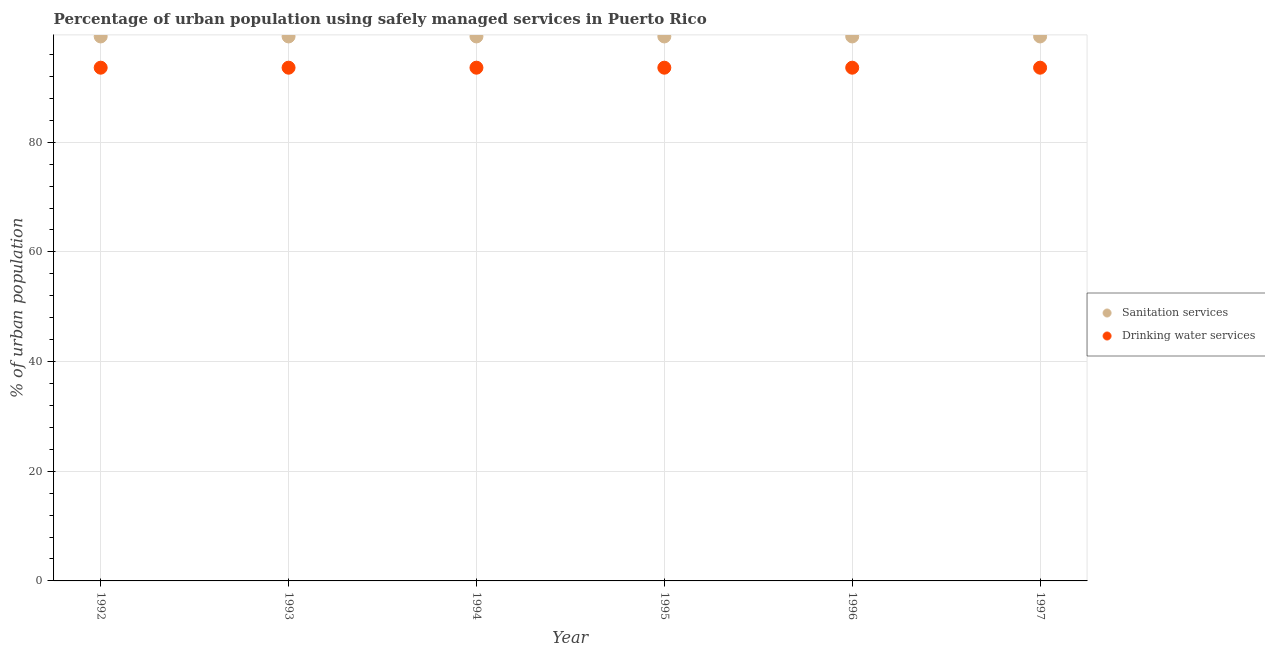Is the number of dotlines equal to the number of legend labels?
Give a very brief answer. Yes. What is the percentage of urban population who used sanitation services in 1993?
Your response must be concise. 99.3. Across all years, what is the maximum percentage of urban population who used drinking water services?
Ensure brevity in your answer.  93.6. Across all years, what is the minimum percentage of urban population who used sanitation services?
Ensure brevity in your answer.  99.3. What is the total percentage of urban population who used sanitation services in the graph?
Your answer should be very brief. 595.8. What is the difference between the percentage of urban population who used sanitation services in 1993 and that in 1995?
Provide a succinct answer. 0. What is the difference between the percentage of urban population who used drinking water services in 1996 and the percentage of urban population who used sanitation services in 1995?
Provide a succinct answer. -5.7. What is the average percentage of urban population who used drinking water services per year?
Make the answer very short. 93.6. In the year 1994, what is the difference between the percentage of urban population who used sanitation services and percentage of urban population who used drinking water services?
Your answer should be very brief. 5.7. What is the ratio of the percentage of urban population who used sanitation services in 1994 to that in 1996?
Keep it short and to the point. 1. Is the percentage of urban population who used sanitation services in 1992 less than that in 1994?
Make the answer very short. No. Is the difference between the percentage of urban population who used drinking water services in 1992 and 1996 greater than the difference between the percentage of urban population who used sanitation services in 1992 and 1996?
Offer a terse response. No. What is the difference between the highest and the second highest percentage of urban population who used drinking water services?
Provide a succinct answer. 0. What is the difference between the highest and the lowest percentage of urban population who used sanitation services?
Your answer should be very brief. 0. How many years are there in the graph?
Offer a very short reply. 6. What is the difference between two consecutive major ticks on the Y-axis?
Offer a terse response. 20. Does the graph contain any zero values?
Offer a very short reply. No. Where does the legend appear in the graph?
Keep it short and to the point. Center right. How many legend labels are there?
Offer a terse response. 2. What is the title of the graph?
Make the answer very short. Percentage of urban population using safely managed services in Puerto Rico. What is the label or title of the Y-axis?
Your answer should be very brief. % of urban population. What is the % of urban population of Sanitation services in 1992?
Your response must be concise. 99.3. What is the % of urban population of Drinking water services in 1992?
Offer a very short reply. 93.6. What is the % of urban population of Sanitation services in 1993?
Your response must be concise. 99.3. What is the % of urban population in Drinking water services in 1993?
Provide a succinct answer. 93.6. What is the % of urban population of Sanitation services in 1994?
Give a very brief answer. 99.3. What is the % of urban population in Drinking water services in 1994?
Provide a succinct answer. 93.6. What is the % of urban population in Sanitation services in 1995?
Provide a short and direct response. 99.3. What is the % of urban population of Drinking water services in 1995?
Offer a terse response. 93.6. What is the % of urban population in Sanitation services in 1996?
Offer a terse response. 99.3. What is the % of urban population in Drinking water services in 1996?
Your answer should be compact. 93.6. What is the % of urban population in Sanitation services in 1997?
Ensure brevity in your answer.  99.3. What is the % of urban population of Drinking water services in 1997?
Your response must be concise. 93.6. Across all years, what is the maximum % of urban population of Sanitation services?
Keep it short and to the point. 99.3. Across all years, what is the maximum % of urban population of Drinking water services?
Your answer should be compact. 93.6. Across all years, what is the minimum % of urban population of Sanitation services?
Keep it short and to the point. 99.3. Across all years, what is the minimum % of urban population of Drinking water services?
Provide a succinct answer. 93.6. What is the total % of urban population of Sanitation services in the graph?
Your answer should be compact. 595.8. What is the total % of urban population in Drinking water services in the graph?
Give a very brief answer. 561.6. What is the difference between the % of urban population in Drinking water services in 1992 and that in 1993?
Make the answer very short. 0. What is the difference between the % of urban population of Sanitation services in 1992 and that in 1994?
Give a very brief answer. 0. What is the difference between the % of urban population in Sanitation services in 1992 and that in 1997?
Keep it short and to the point. 0. What is the difference between the % of urban population in Drinking water services in 1992 and that in 1997?
Provide a succinct answer. 0. What is the difference between the % of urban population of Drinking water services in 1993 and that in 1996?
Provide a short and direct response. 0. What is the difference between the % of urban population in Sanitation services in 1993 and that in 1997?
Provide a short and direct response. 0. What is the difference between the % of urban population in Sanitation services in 1994 and that in 1995?
Your response must be concise. 0. What is the difference between the % of urban population in Drinking water services in 1994 and that in 1996?
Keep it short and to the point. 0. What is the difference between the % of urban population in Sanitation services in 1995 and that in 1996?
Make the answer very short. 0. What is the difference between the % of urban population of Sanitation services in 1995 and that in 1997?
Give a very brief answer. 0. What is the difference between the % of urban population in Drinking water services in 1995 and that in 1997?
Provide a short and direct response. 0. What is the difference between the % of urban population in Sanitation services in 1992 and the % of urban population in Drinking water services in 1994?
Provide a succinct answer. 5.7. What is the difference between the % of urban population of Sanitation services in 1992 and the % of urban population of Drinking water services in 1997?
Provide a succinct answer. 5.7. What is the difference between the % of urban population in Sanitation services in 1993 and the % of urban population in Drinking water services in 1994?
Ensure brevity in your answer.  5.7. What is the difference between the % of urban population of Sanitation services in 1993 and the % of urban population of Drinking water services in 1995?
Your response must be concise. 5.7. What is the difference between the % of urban population of Sanitation services in 1993 and the % of urban population of Drinking water services in 1996?
Your answer should be compact. 5.7. What is the difference between the % of urban population of Sanitation services in 1993 and the % of urban population of Drinking water services in 1997?
Offer a very short reply. 5.7. What is the difference between the % of urban population in Sanitation services in 1994 and the % of urban population in Drinking water services in 1995?
Make the answer very short. 5.7. What is the difference between the % of urban population of Sanitation services in 1995 and the % of urban population of Drinking water services in 1997?
Provide a succinct answer. 5.7. What is the average % of urban population of Sanitation services per year?
Provide a succinct answer. 99.3. What is the average % of urban population of Drinking water services per year?
Keep it short and to the point. 93.6. In the year 1992, what is the difference between the % of urban population in Sanitation services and % of urban population in Drinking water services?
Ensure brevity in your answer.  5.7. In the year 1994, what is the difference between the % of urban population of Sanitation services and % of urban population of Drinking water services?
Offer a terse response. 5.7. In the year 1996, what is the difference between the % of urban population in Sanitation services and % of urban population in Drinking water services?
Ensure brevity in your answer.  5.7. In the year 1997, what is the difference between the % of urban population of Sanitation services and % of urban population of Drinking water services?
Provide a short and direct response. 5.7. What is the ratio of the % of urban population of Sanitation services in 1992 to that in 1993?
Give a very brief answer. 1. What is the ratio of the % of urban population of Drinking water services in 1992 to that in 1993?
Make the answer very short. 1. What is the ratio of the % of urban population of Sanitation services in 1992 to that in 1994?
Keep it short and to the point. 1. What is the ratio of the % of urban population in Drinking water services in 1992 to that in 1995?
Ensure brevity in your answer.  1. What is the ratio of the % of urban population of Sanitation services in 1992 to that in 1996?
Provide a succinct answer. 1. What is the ratio of the % of urban population of Drinking water services in 1992 to that in 1996?
Offer a terse response. 1. What is the ratio of the % of urban population in Sanitation services in 1993 to that in 1995?
Provide a short and direct response. 1. What is the ratio of the % of urban population of Drinking water services in 1993 to that in 1995?
Your answer should be compact. 1. What is the ratio of the % of urban population of Sanitation services in 1993 to that in 1996?
Make the answer very short. 1. What is the ratio of the % of urban population of Sanitation services in 1993 to that in 1997?
Give a very brief answer. 1. What is the ratio of the % of urban population of Sanitation services in 1994 to that in 1995?
Your answer should be compact. 1. What is the ratio of the % of urban population in Sanitation services in 1994 to that in 1997?
Offer a very short reply. 1. What is the ratio of the % of urban population in Sanitation services in 1995 to that in 1997?
Keep it short and to the point. 1. What is the ratio of the % of urban population in Drinking water services in 1995 to that in 1997?
Offer a terse response. 1. What is the difference between the highest and the second highest % of urban population of Sanitation services?
Provide a short and direct response. 0. What is the difference between the highest and the second highest % of urban population in Drinking water services?
Make the answer very short. 0. 